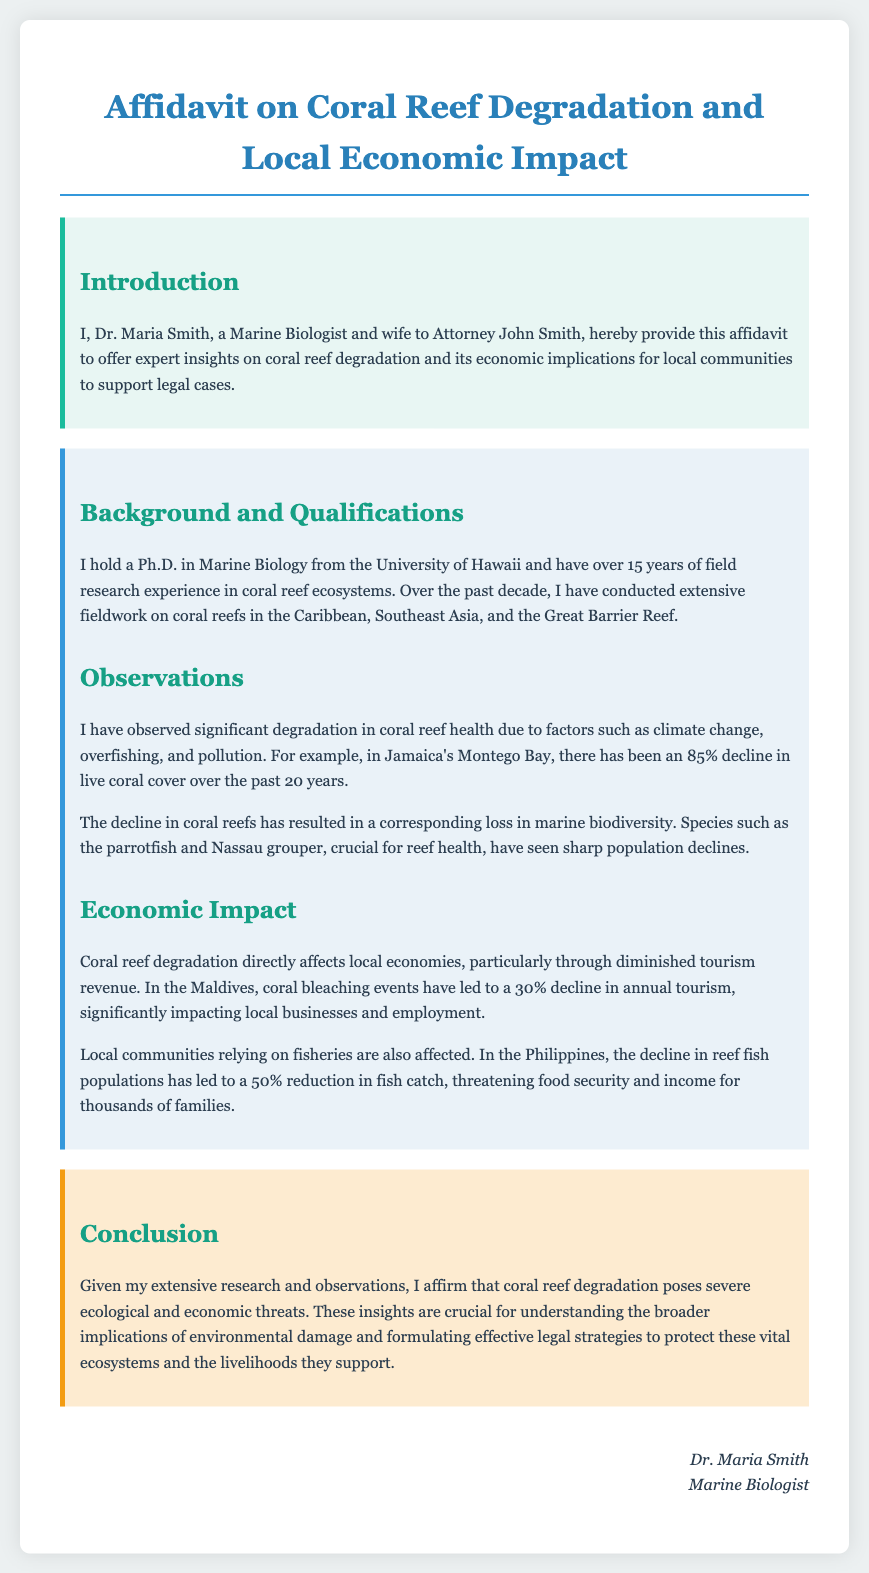What is the name of the author? The author's name appears at the end of the document, identifying her as Dr. Maria Smith.
Answer: Dr. Maria Smith What is Dr. Maria Smith's highest degree? The document states that Dr. Maria Smith holds a Ph.D. in Marine Biology from the University of Hawaii.
Answer: Ph.D What percentage decline in live coral cover was observed in Jamaica's Montego Bay? The document specifies an 85% decline in live coral cover in Jamaica's Montego Bay over the past 20 years.
Answer: 85% What was the economic impact of coral bleaching events in the Maldives? According to the document, coral bleaching events in the Maldives led to a 30% decline in annual tourism.
Answer: 30% Which species are mentioned as crucial for reef health? The document mentions parrotfish and Nassau grouper as crucial species for reef health.
Answer: Parrotfish and Nassau grouper What time span does Dr. Maria Smith's field research cover? The document indicates that Dr. Maria Smith has over 15 years of field research experience.
Answer: 15 years In which regions has Dr. Maria Smith conducted fieldwork? The document states that she has worked in the Caribbean, Southeast Asia, and the Great Barrier Reef.
Answer: Caribbean, Southeast Asia, Great Barrier Reef What is the main conclusion of Dr. Maria Smith's affidavit? The document concludes that coral reef degradation poses severe ecological and economic threats.
Answer: Severe ecological and economic threats What type of document is this? The introduction indicates that this text is an affidavit supporting legal cases regarding environmental issues.
Answer: Affidavit 